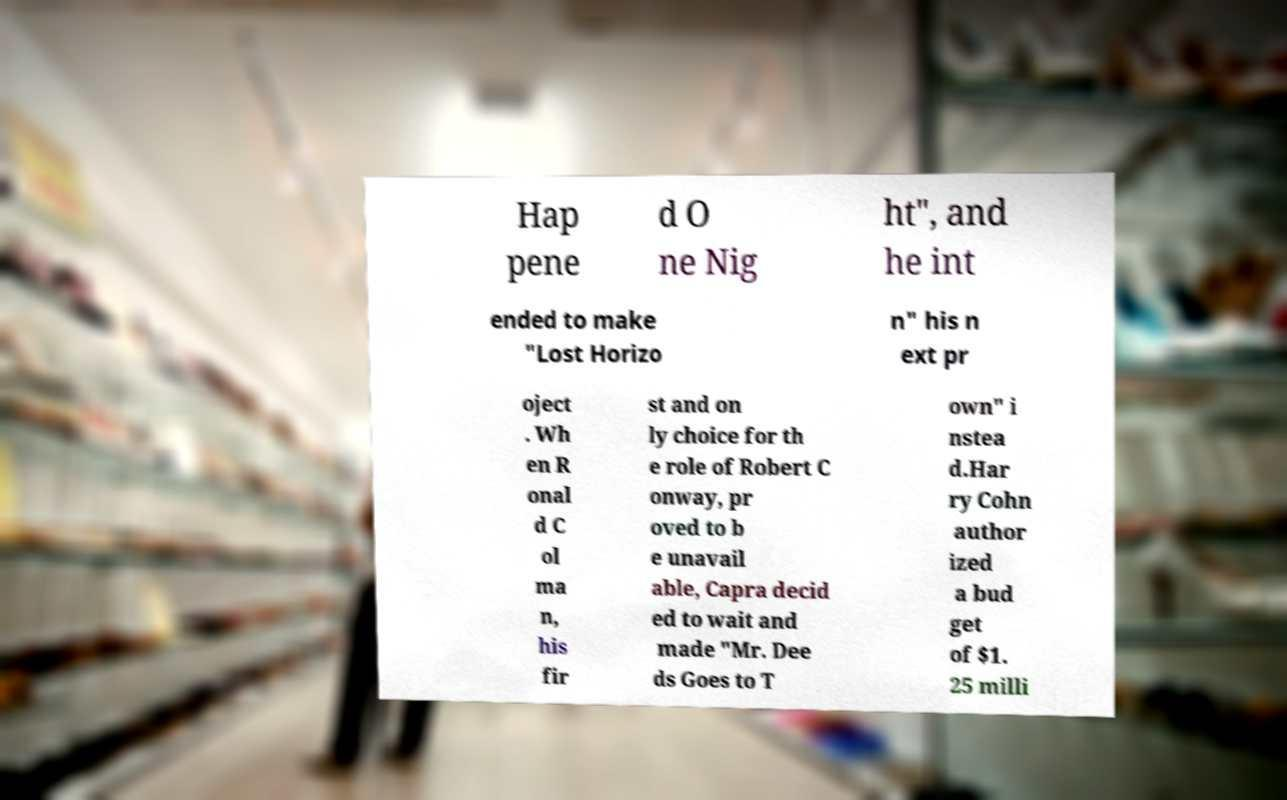Can you read and provide the text displayed in the image?This photo seems to have some interesting text. Can you extract and type it out for me? Hap pene d O ne Nig ht", and he int ended to make "Lost Horizo n" his n ext pr oject . Wh en R onal d C ol ma n, his fir st and on ly choice for th e role of Robert C onway, pr oved to b e unavail able, Capra decid ed to wait and made "Mr. Dee ds Goes to T own" i nstea d.Har ry Cohn author ized a bud get of $1. 25 milli 